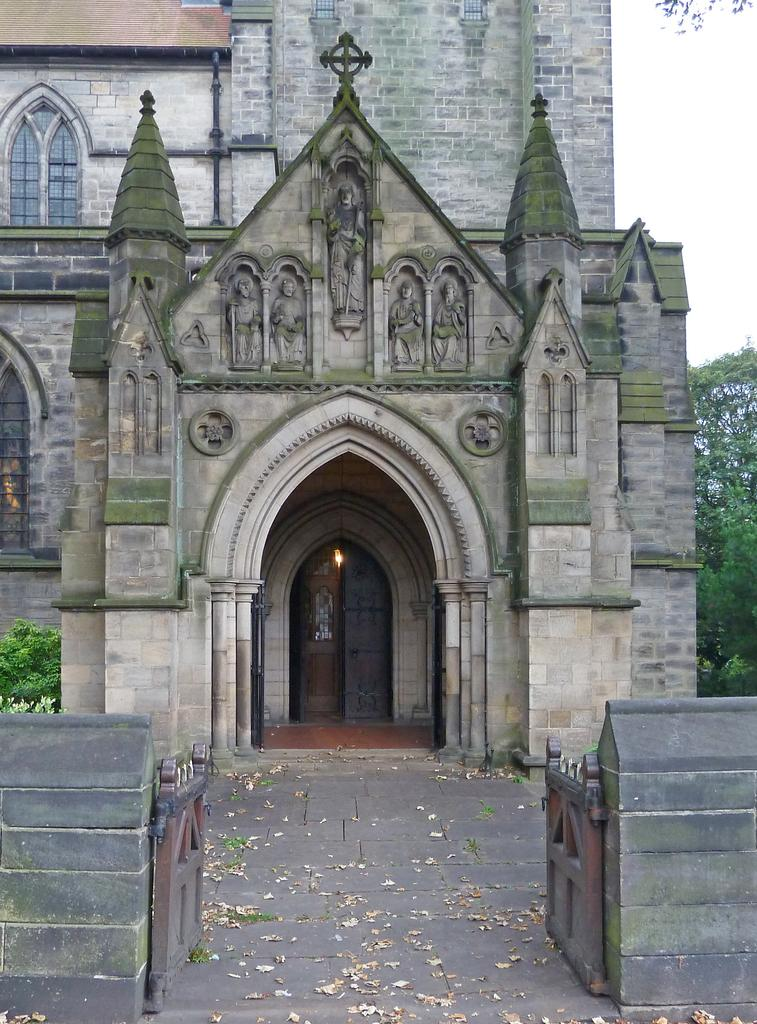What type of structure is present in the image? There is a building in the image. What feature can be seen on the building? The building has windows. What is the entrance to the building in the image? There is a gate in the image. What type of vegetation is present in the image? There are trees in the image. What is the color of the sky in the image? The sky is white in color. What type of birthday celebration is taking place in the image? There is no indication of a birthday celebration in the image. What idea is being discussed in the image? There is no discussion or idea present in the image; it is a static scene featuring a building, windows, a gate, trees, and a white sky. 